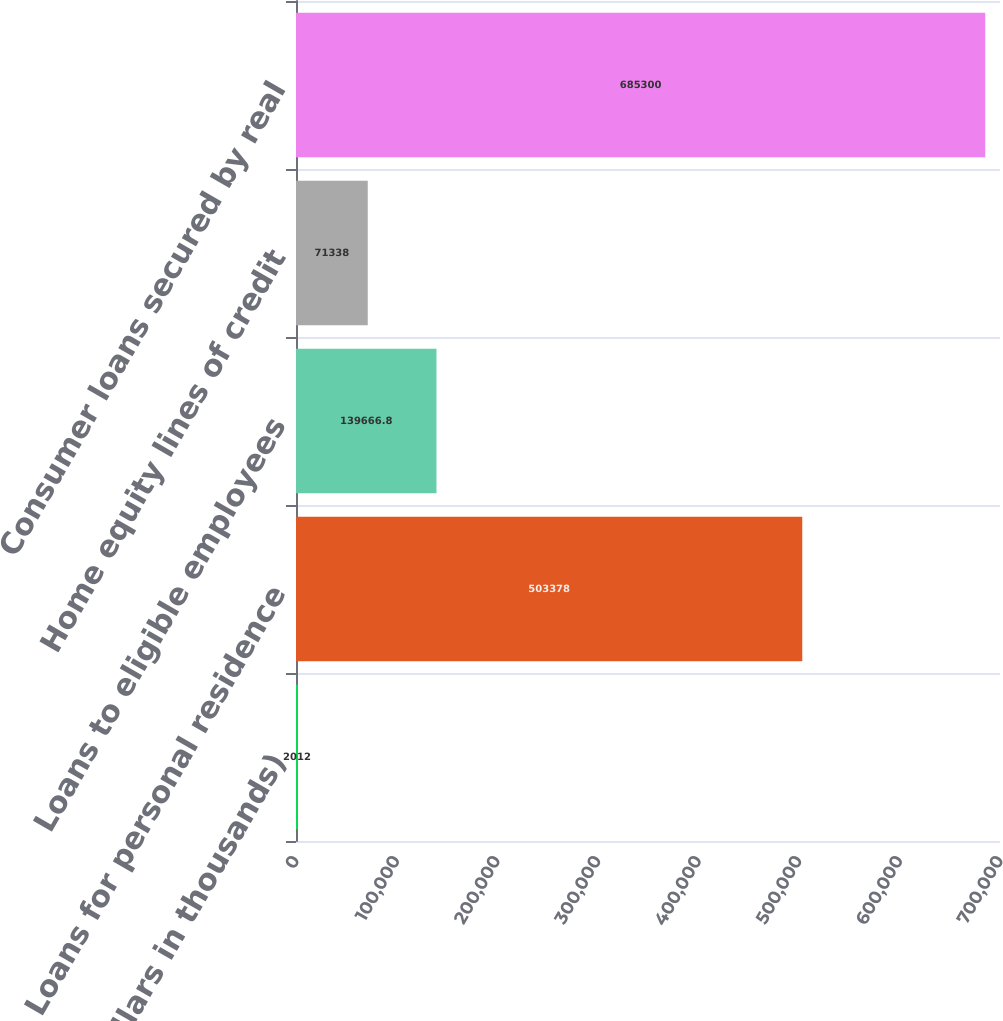Convert chart. <chart><loc_0><loc_0><loc_500><loc_500><bar_chart><fcel>(Dollars in thousands)<fcel>Loans for personal residence<fcel>Loans to eligible employees<fcel>Home equity lines of credit<fcel>Consumer loans secured by real<nl><fcel>2012<fcel>503378<fcel>139667<fcel>71338<fcel>685300<nl></chart> 